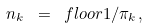Convert formula to latex. <formula><loc_0><loc_0><loc_500><loc_500>n _ { k } \ = \ f l o o r { 1 / \pi _ { k } } ,</formula> 